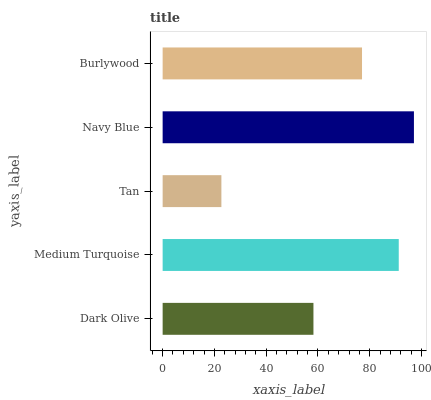Is Tan the minimum?
Answer yes or no. Yes. Is Navy Blue the maximum?
Answer yes or no. Yes. Is Medium Turquoise the minimum?
Answer yes or no. No. Is Medium Turquoise the maximum?
Answer yes or no. No. Is Medium Turquoise greater than Dark Olive?
Answer yes or no. Yes. Is Dark Olive less than Medium Turquoise?
Answer yes or no. Yes. Is Dark Olive greater than Medium Turquoise?
Answer yes or no. No. Is Medium Turquoise less than Dark Olive?
Answer yes or no. No. Is Burlywood the high median?
Answer yes or no. Yes. Is Burlywood the low median?
Answer yes or no. Yes. Is Tan the high median?
Answer yes or no. No. Is Medium Turquoise the low median?
Answer yes or no. No. 